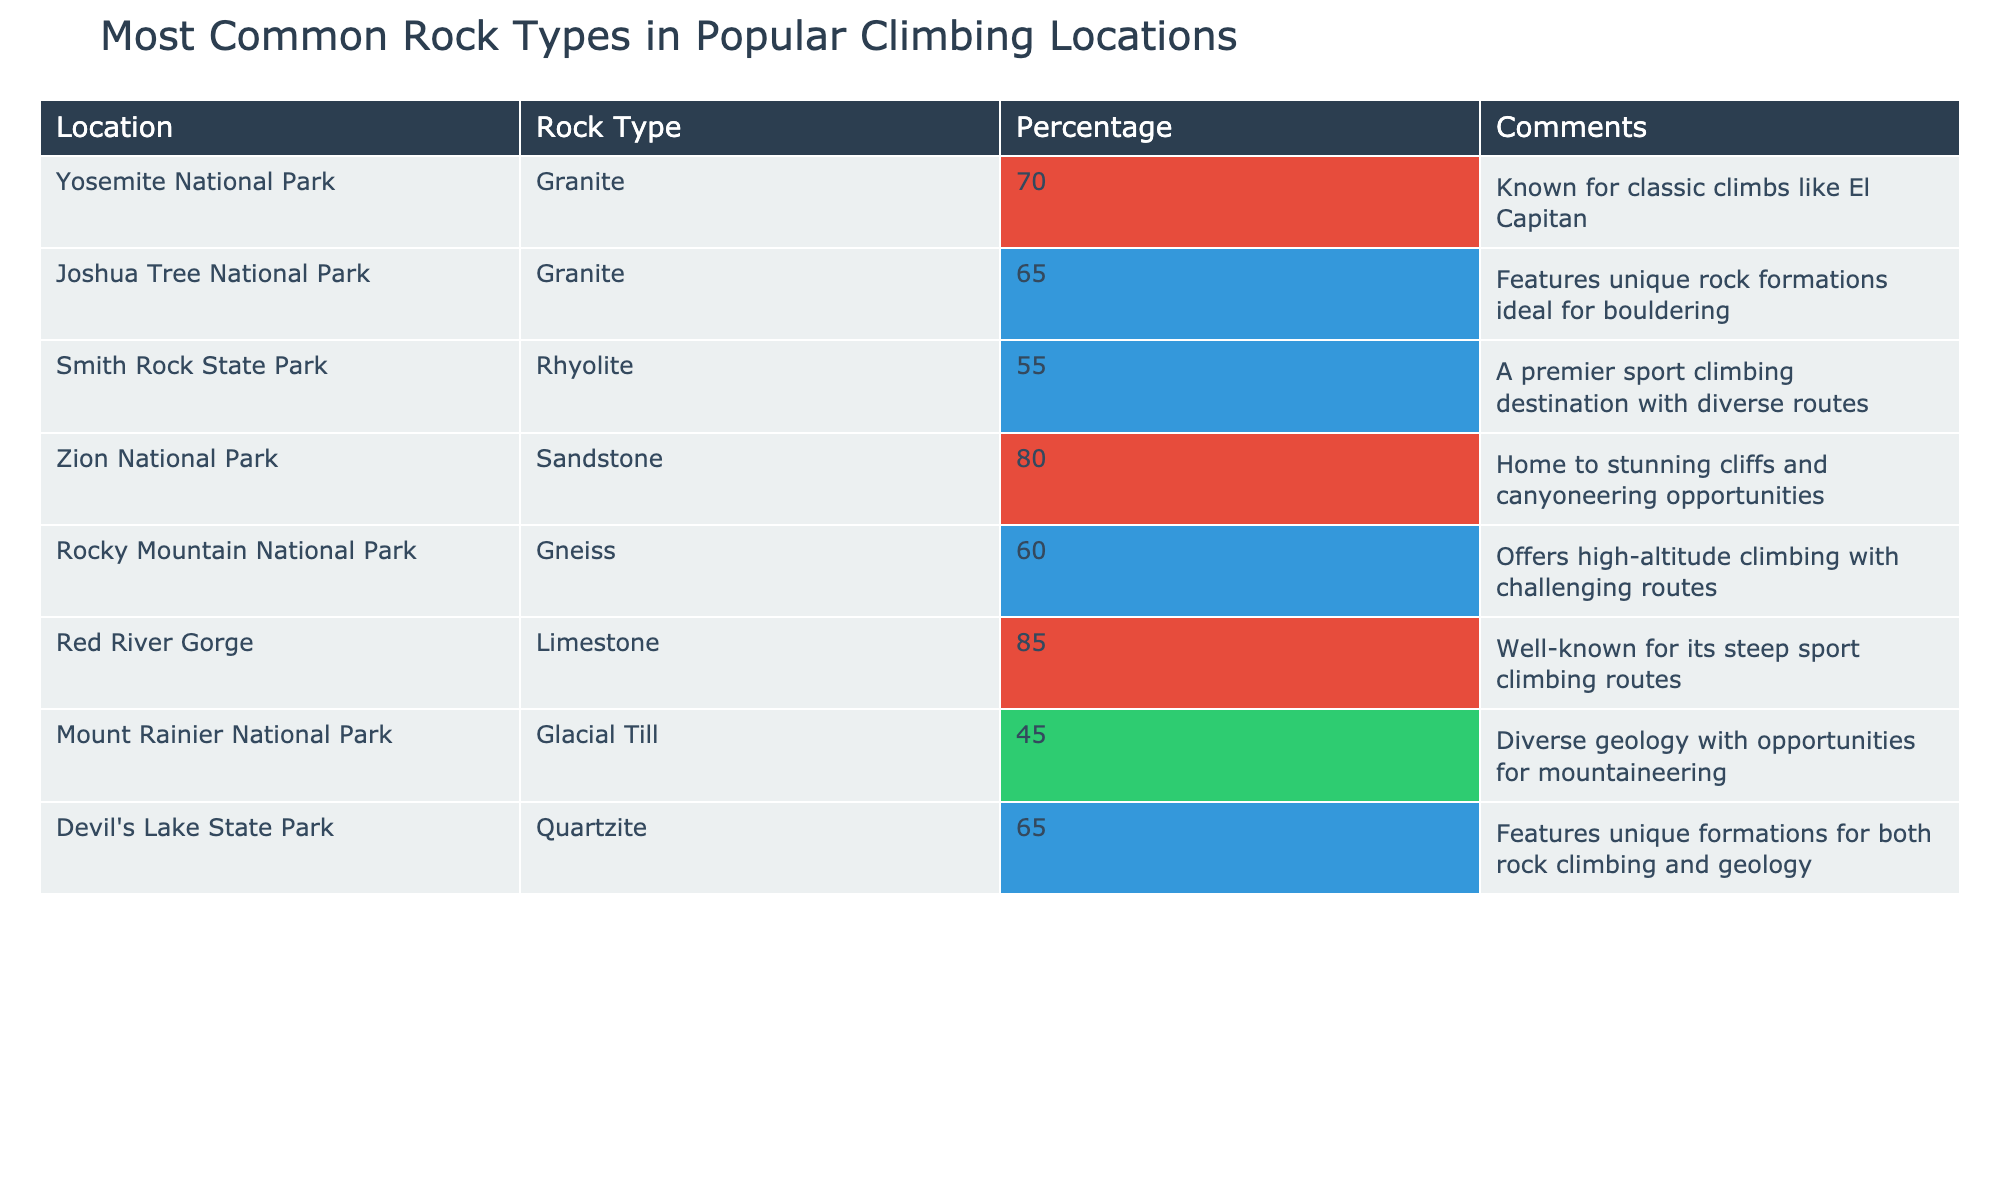What is the most common rock type found in Zion National Park? The table indicates that Zion National Park has Sandstone as the rock type with a percentage of 80%.
Answer: Sandstone Which climbing location features the lowest percentage of its common rock type? Looking down the Percentage column, Mount Rainier National Park has the lowest percentage of 45% for Glacial Till.
Answer: Mount Rainier National Park Is Granite more commonly found than Limestone in climbing locations according to the table? The percentages show Granite is present in Yosemite (70%) and Joshua Tree (65%), whereas Limestone is represented only in Red River Gorge (85%). Therefore, Granite appears more often but averages less.
Answer: No What is the total percentage of common rock types across all locations listed? Adding all the percentages together gives: 70 + 65 + 55 + 80 + 60 + 85 + 45 + 65 = 615. There are 8 locations, so the average percentage is 615 / 8 = 76.875.
Answer: 76.875 Which climbing location has the highest percentage for its rock type, and what is that rock type? Red River Gorge has the highest percentage for its rock type, which is Limestone at 85%.
Answer: Red River Gorge, Limestone If you were to arrange all locations by rock type percentage, which location would be in the middle? The sorted percentages in descending order are: 85% (Red River Gorge), 80% (Zion National Park), 70% (Yosemite National Park), 65% (Joshua Tree and Devil's Lake), 65% (Quartzite), 60% (Rocky Mountain National Park), 55% (Smith Rock), and 45% (Mount Rainier). The middle location's percentage is 65%.
Answer: Joshua Tree or Devil's Lake Is there any location where Glacial Till is the most common rock type? The only location with Glacial Till is Mount Rainier National Park at 45%, which is not the highest compared to other rock types.
Answer: No Which rock type has the highest occurrence among those listed in the table? Analyzing the table, Granite appears in both Yosemite (70%) and Joshua Tree (65%), while other types are represented only once, thus making it the most common.
Answer: Granite 